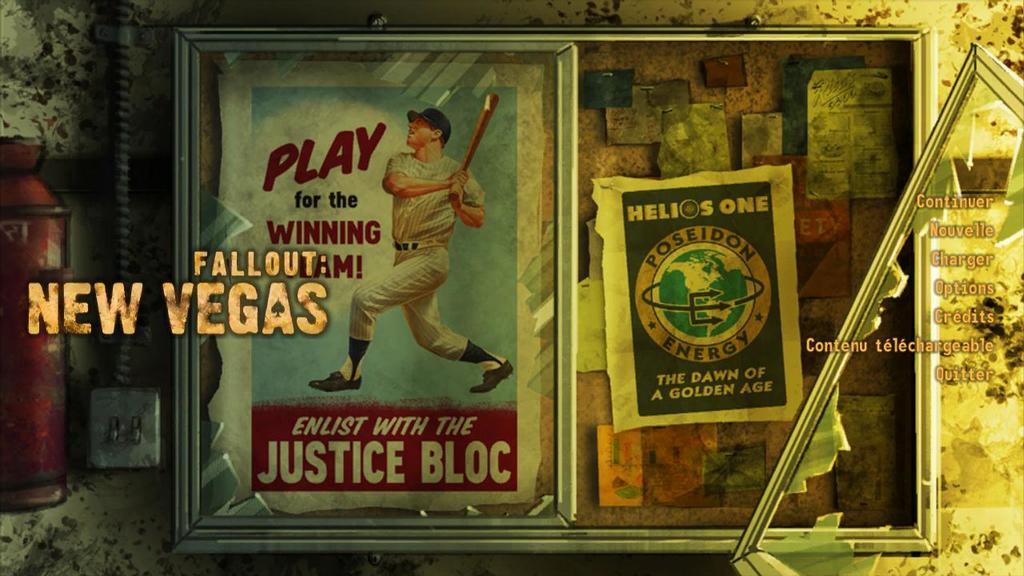What is the name of the game?
Offer a very short reply. Fallout new vegas. What is the tagline of the poster on the left?
Your answer should be very brief. Play for the winning team!. 